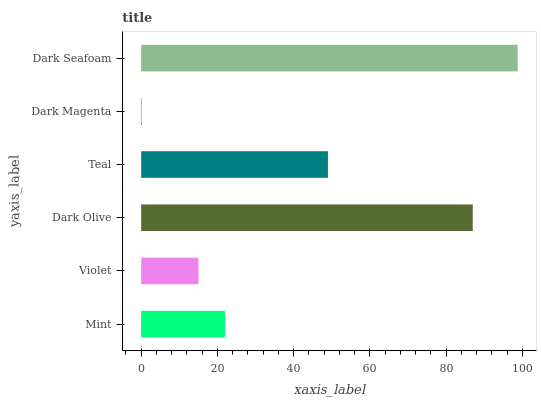Is Dark Magenta the minimum?
Answer yes or no. Yes. Is Dark Seafoam the maximum?
Answer yes or no. Yes. Is Violet the minimum?
Answer yes or no. No. Is Violet the maximum?
Answer yes or no. No. Is Mint greater than Violet?
Answer yes or no. Yes. Is Violet less than Mint?
Answer yes or no. Yes. Is Violet greater than Mint?
Answer yes or no. No. Is Mint less than Violet?
Answer yes or no. No. Is Teal the high median?
Answer yes or no. Yes. Is Mint the low median?
Answer yes or no. Yes. Is Dark Seafoam the high median?
Answer yes or no. No. Is Dark Seafoam the low median?
Answer yes or no. No. 